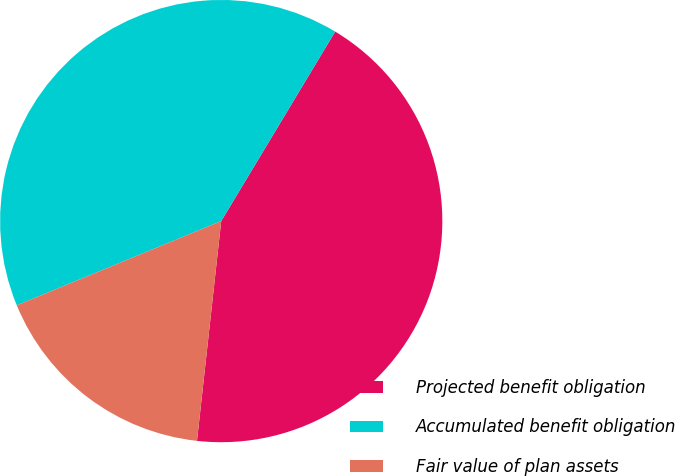<chart> <loc_0><loc_0><loc_500><loc_500><pie_chart><fcel>Projected benefit obligation<fcel>Accumulated benefit obligation<fcel>Fair value of plan assets<nl><fcel>43.13%<fcel>39.84%<fcel>17.03%<nl></chart> 